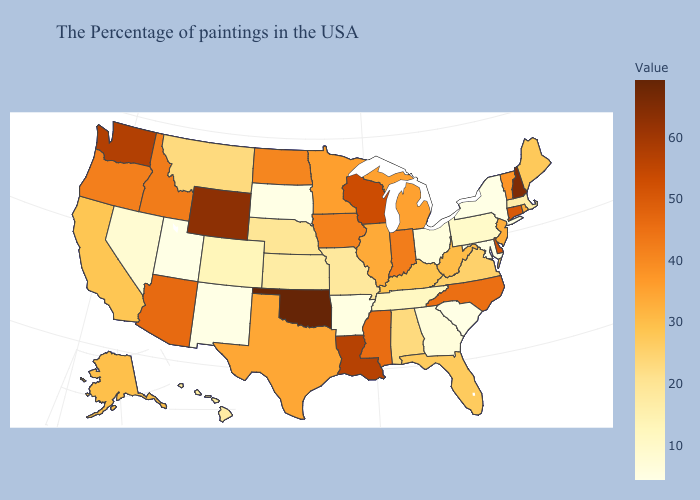Does Minnesota have a higher value than New Hampshire?
Give a very brief answer. No. Does Oklahoma have the highest value in the South?
Concise answer only. Yes. Which states have the lowest value in the USA?
Quick response, please. New York, Maryland, South Carolina, South Dakota, New Mexico, Utah. Among the states that border North Dakota , does Montana have the highest value?
Concise answer only. No. Does Minnesota have a lower value than New Hampshire?
Quick response, please. Yes. 